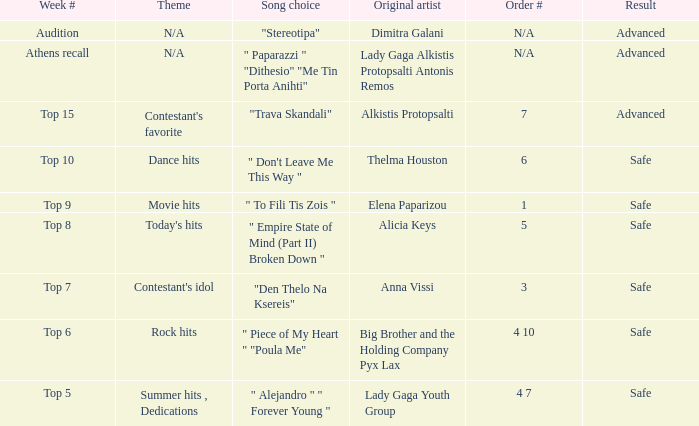What are all the order #s from the week "top 6"? 4 10. 